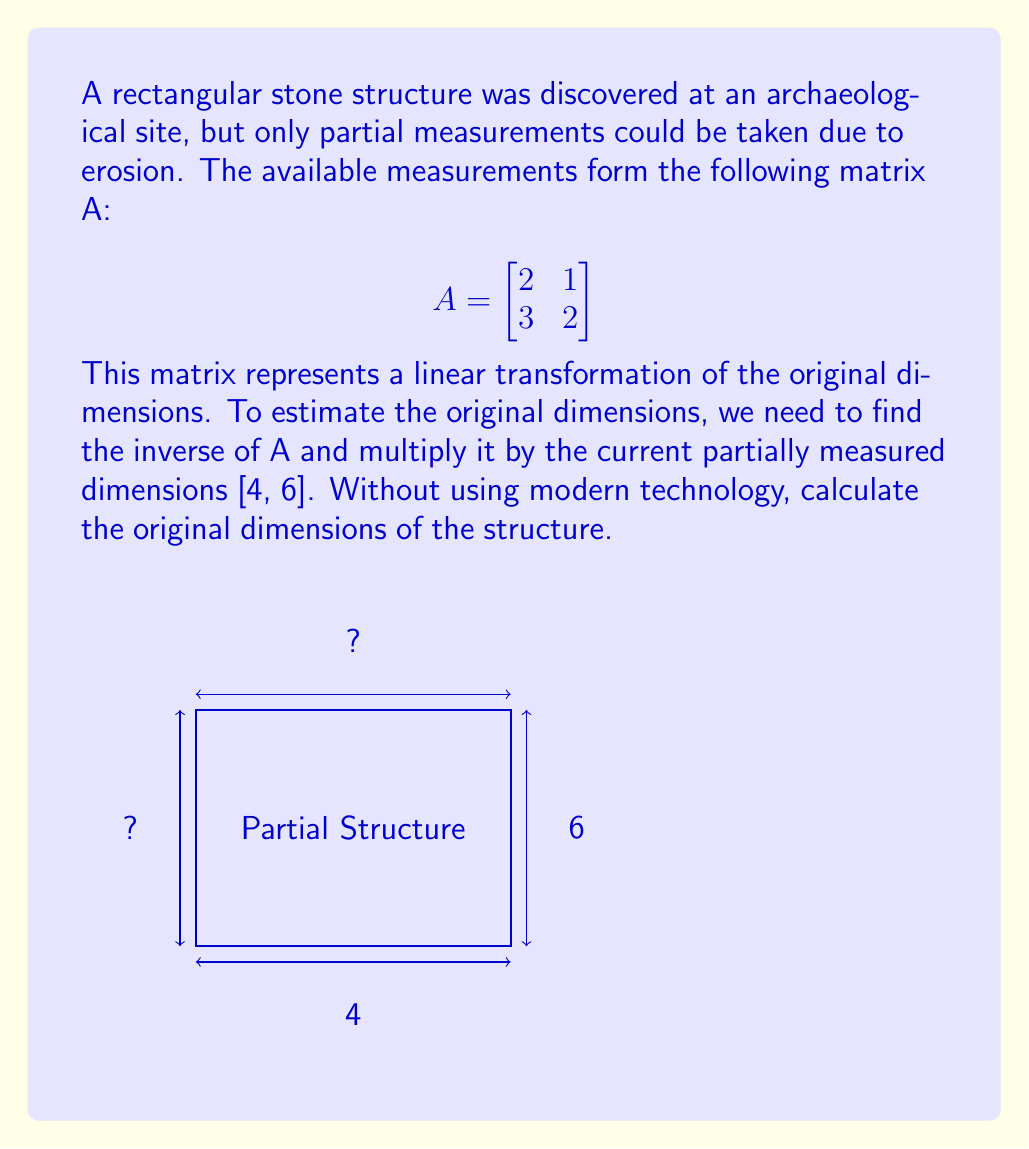Can you solve this math problem? To solve this problem without modern technology, we'll use traditional matrix inversion techniques:

1) First, we need to find the determinant of A:
   $$det(A) = (2 \times 2) - (1 \times 3) = 4 - 3 = 1$$

2) Now, we can find the adjugate matrix:
   $$adj(A) = \begin{bmatrix}
   2 & -1 \\
   -3 & 2
   \end{bmatrix}$$

3) The inverse of A is given by:
   $$A^{-1} = \frac{1}{det(A)} \times adj(A) = \begin{bmatrix}
   2 & -1 \\
   -3 & 2
   \end{bmatrix}$$

4) Now, we multiply $A^{-1}$ by the current dimensions [4, 6]:
   $$\begin{bmatrix}
   2 & -1 \\
   -3 & 2
   \end{bmatrix} \times \begin{bmatrix}
   4 \\
   6
   \end{bmatrix}$$

5) Performing the multiplication:
   $$\begin{bmatrix}
   (2 \times 4) + (-1 \times 6) \\
   (-3 \times 4) + (2 \times 6)
   \end{bmatrix} = \begin{bmatrix}
   8 - 6 \\
   -12 + 12
   \end{bmatrix} = \begin{bmatrix}
   2 \\
   0
   \end{bmatrix}$$

Therefore, the original dimensions of the structure were 2 units in width and 0 units in height.
Answer: [2, 0] 